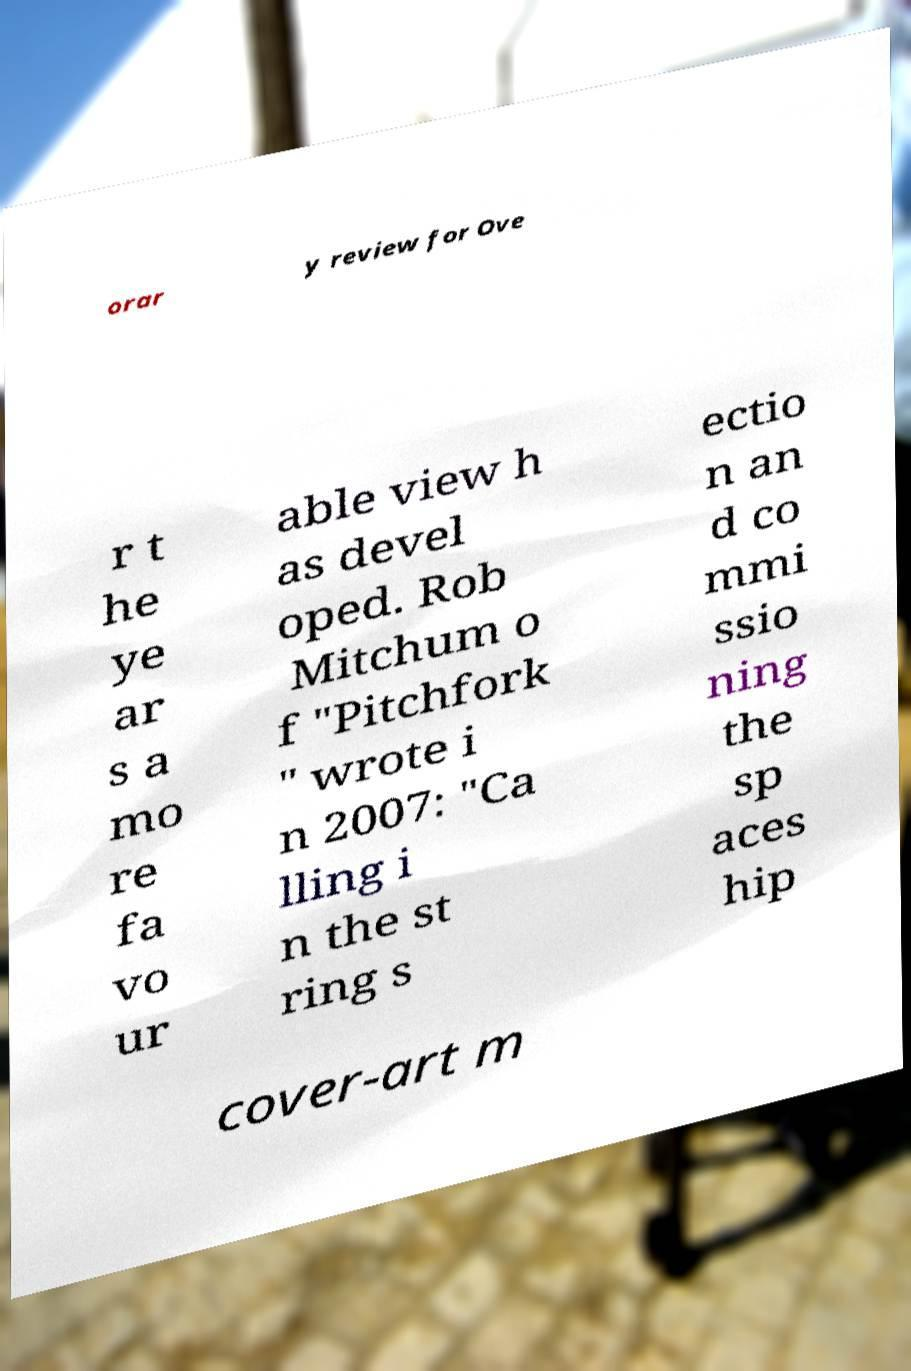Can you read and provide the text displayed in the image?This photo seems to have some interesting text. Can you extract and type it out for me? orar y review for Ove r t he ye ar s a mo re fa vo ur able view h as devel oped. Rob Mitchum o f "Pitchfork " wrote i n 2007: "Ca lling i n the st ring s ectio n an d co mmi ssio ning the sp aces hip cover-art m 